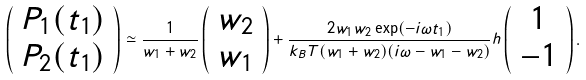<formula> <loc_0><loc_0><loc_500><loc_500>\left ( \begin{array} { c } P _ { 1 } ( t _ { 1 } ) \\ P _ { 2 } ( t _ { 1 } ) \end{array} \right ) \simeq \frac { 1 } { w _ { 1 } + w _ { 2 } } \left ( \begin{array} { c } w _ { 2 } \\ w _ { 1 } \end{array} \right ) + \frac { 2 w _ { 1 } w _ { 2 } \exp ( - i \omega t _ { 1 } ) } { k _ { B } T ( w _ { 1 } + w _ { 2 } ) ( i \omega - w _ { 1 } - w _ { 2 } ) } h \left ( \begin{array} { c } 1 \\ - 1 \end{array} \right ) .</formula> 